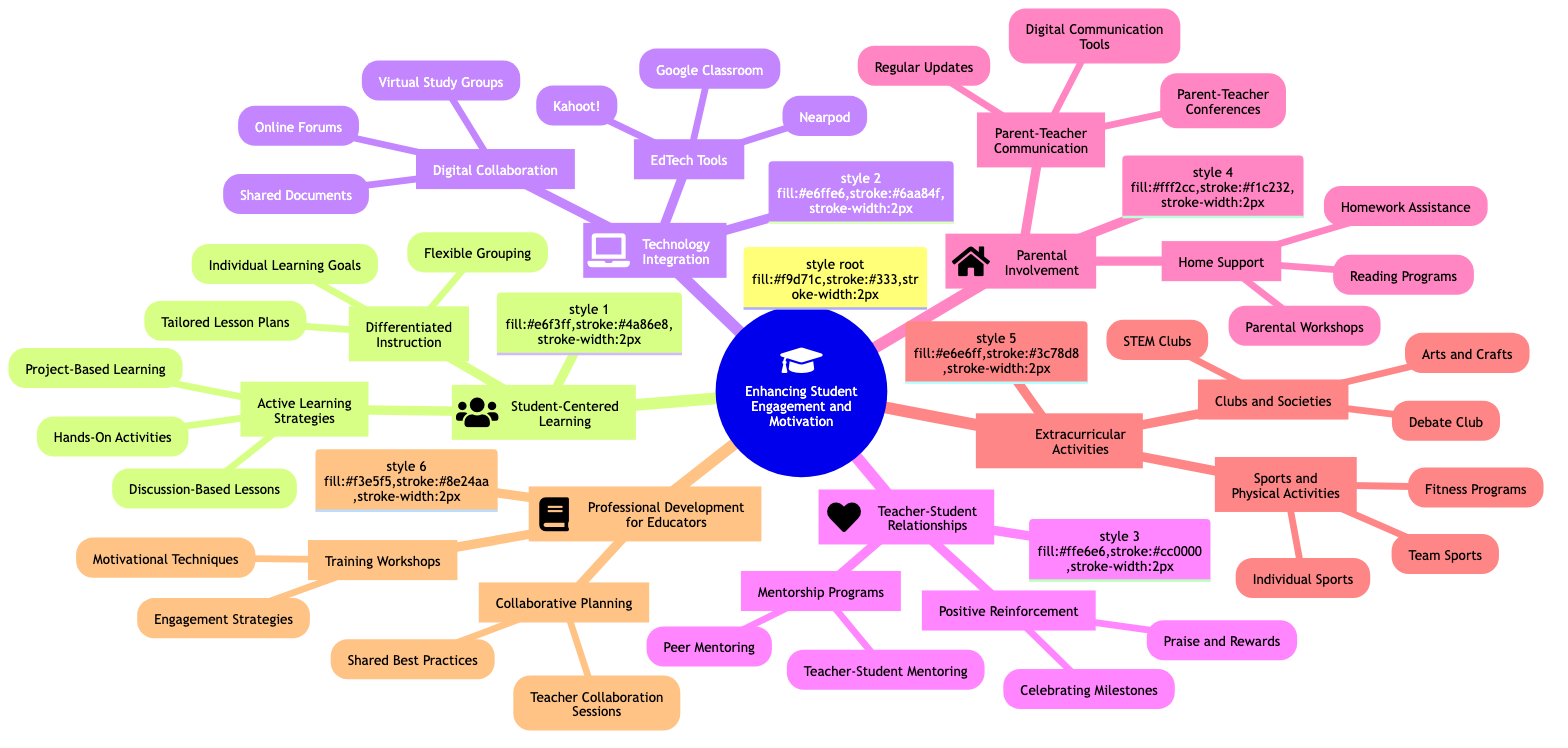What are the categories listed under "Enhancing Student Engagement and Motivation"? The main categories listed under "Enhancing Student Engagement and Motivation" are: Student-Centered Learning, Technology Integration, Teacher-Student Relationships, Parental Involvement, Extracurricular Activities, and Professional Development for Educators.
Answer: Student-Centered Learning, Technology Integration, Teacher-Student Relationships, Parental Involvement, Extracurricular Activities, Professional Development for Educators How many strategies are mentioned under "Technology Integration"? Under "Technology Integration", there are two main strategies: EdTech Tools and Digital Collaboration. Each of these strategies has three sub-items listed. Thus, the number of strategies is 2.
Answer: 2 Which tool is listed as an EdTech tool? One of the tools listed under "EdTech Tools" is Google Classroom. It is part of the technology integration category designed to enhance student engagement through digital means.
Answer: Google Classroom What is the relationship between "Mentorship Programs" and "Teacher-Student Relationships"? "Mentorship Programs" is a sub-category under "Teacher-Student Relationships". This indicates that these programs are intended to foster better relationships between teachers and students, highlighting their function within the broader topic of engagement.
Answer: Sub-category Which activity falls under "Extracurricular Activities" related to sports? "Team Sports" is an activity listed under "Extracurricular Activities" specifically related to sports, which points to physical engagement opportunities beyond the academic curriculum.
Answer: Team Sports What is the number of subcategories under "Professional Development for Educators"? Under "Professional Development for Educators", there are two subcategories: Training Workshops and Collaborative Planning, indicating a focus on improving teacher effectiveness through various methods.
Answer: 2 What are the forms of home support mentioned? The forms of home support mentioned include Homework Assistance, Reading Programs, and Parental Workshops, which are ways to involve parents in their children's education at home.
Answer: Homework Assistance, Reading Programs, Parental Workshops Which strategy includes "Praise and Rewards"? "Praise and Rewards" is included under the "Positive Reinforcement" strategy, which is part of the "Teacher-Student Relationships" category, emphasizing the importance of encouragement in engaging students.
Answer: Positive Reinforcement What kind of learning approach is highlighted under "Active Learning Strategies"? The "Active Learning Strategies" include "Project-Based Learning", which emphasizes engaging students in real-world projects, therefore enhancing their involvement in the learning process.
Answer: Project-Based Learning 